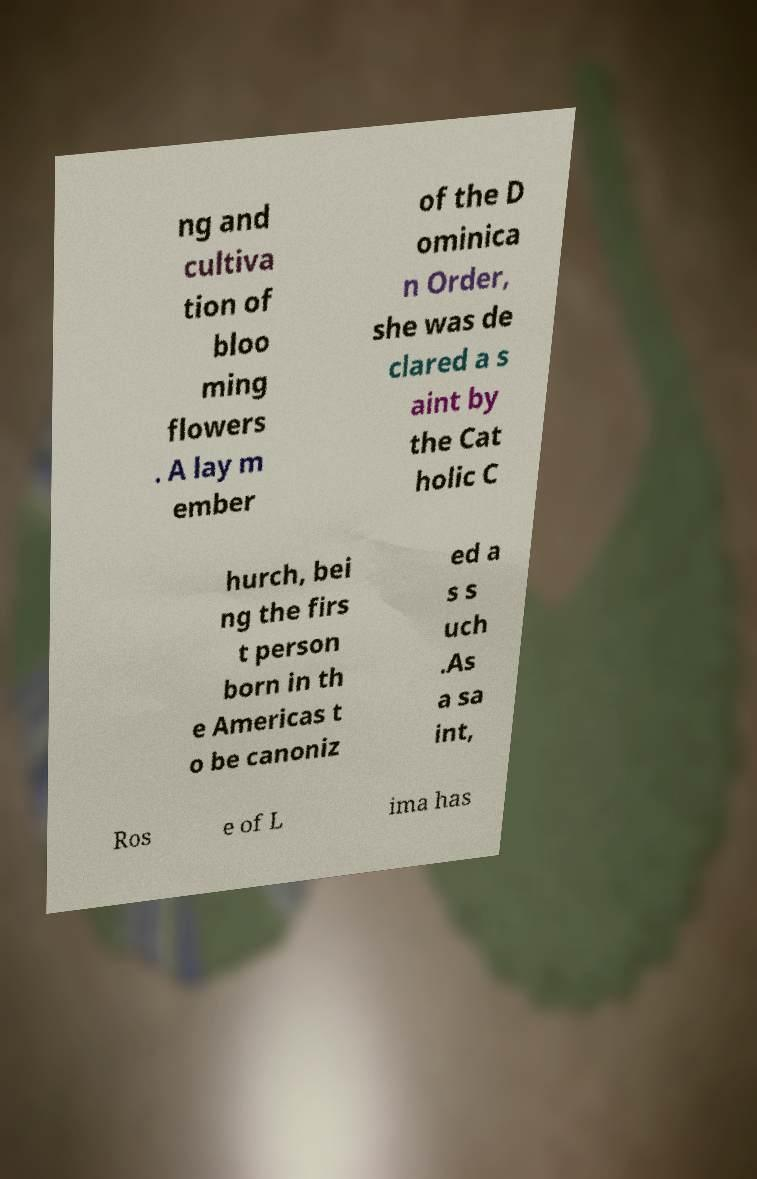Could you assist in decoding the text presented in this image and type it out clearly? ng and cultiva tion of bloo ming flowers . A lay m ember of the D ominica n Order, she was de clared a s aint by the Cat holic C hurch, bei ng the firs t person born in th e Americas t o be canoniz ed a s s uch .As a sa int, Ros e of L ima has 